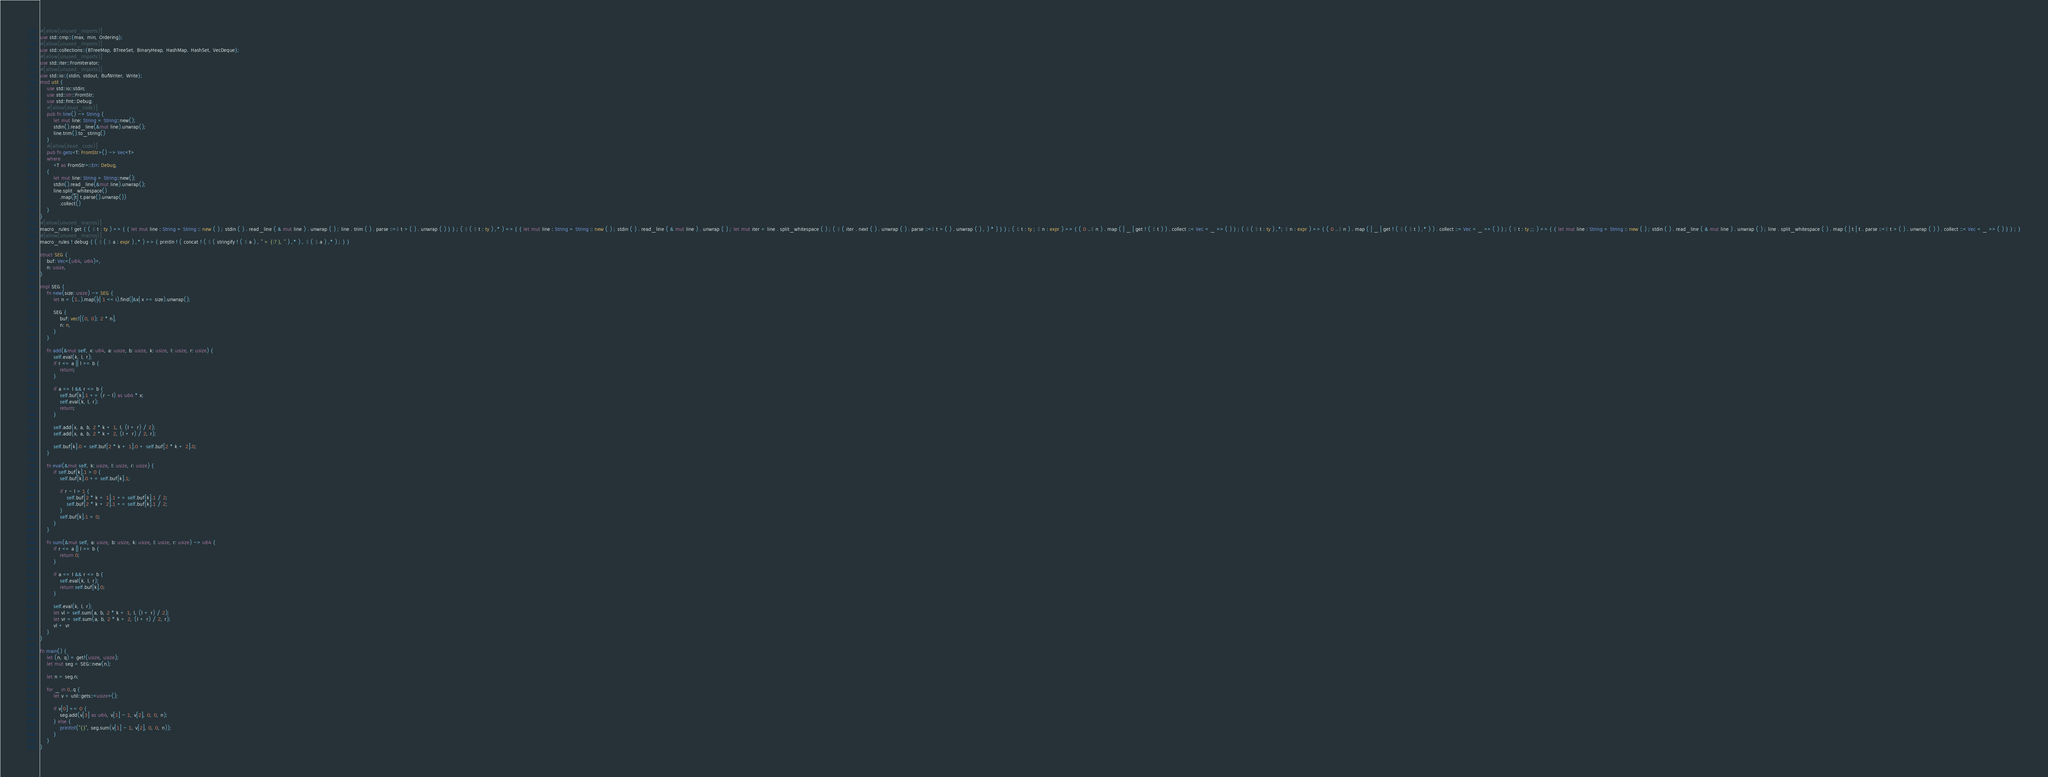<code> <loc_0><loc_0><loc_500><loc_500><_Rust_>#[allow(unused_imports)]
use std::cmp::{max, min, Ordering};
#[allow(unused_imports)]
use std::collections::{BTreeMap, BTreeSet, BinaryHeap, HashMap, HashSet, VecDeque};
#[allow(unused_imports)]
use std::iter::FromIterator;
#[allow(unused_imports)]
use std::io::{stdin, stdout, BufWriter, Write};
mod util {
    use std::io::stdin;
    use std::str::FromStr;
    use std::fmt::Debug;
    #[allow(dead_code)]
    pub fn line() -> String {
        let mut line: String = String::new();
        stdin().read_line(&mut line).unwrap();
        line.trim().to_string()
    }
    #[allow(dead_code)]
    pub fn gets<T: FromStr>() -> Vec<T>
    where
        <T as FromStr>::Err: Debug,
    {
        let mut line: String = String::new();
        stdin().read_line(&mut line).unwrap();
        line.split_whitespace()
            .map(|t| t.parse().unwrap())
            .collect()
    }
}
#[allow(unused_macros)]
macro_rules ! get { ( $ t : ty ) => { { let mut line : String = String :: new ( ) ; stdin ( ) . read_line ( & mut line ) . unwrap ( ) ; line . trim ( ) . parse ::<$ t > ( ) . unwrap ( ) } } ; ( $ ( $ t : ty ) ,* ) => { { let mut line : String = String :: new ( ) ; stdin ( ) . read_line ( & mut line ) . unwrap ( ) ; let mut iter = line . split_whitespace ( ) ; ( $ ( iter . next ( ) . unwrap ( ) . parse ::<$ t > ( ) . unwrap ( ) , ) * ) } } ; ( $ t : ty ; $ n : expr ) => { ( 0 ..$ n ) . map ( | _ | get ! ( $ t ) ) . collect ::< Vec < _ >> ( ) } ; ( $ ( $ t : ty ) ,*; $ n : expr ) => { ( 0 ..$ n ) . map ( | _ | get ! ( $ ( $ t ) ,* ) ) . collect ::< Vec < _ >> ( ) } ; ( $ t : ty ;; ) => { { let mut line : String = String :: new ( ) ; stdin ( ) . read_line ( & mut line ) . unwrap ( ) ; line . split_whitespace ( ) . map ( | t | t . parse ::<$ t > ( ) . unwrap ( ) ) . collect ::< Vec < _ >> ( ) } } ; }
#[allow(unused_macros)]
macro_rules ! debug { ( $ ( $ a : expr ) ,* ) => { println ! ( concat ! ( $ ( stringify ! ( $ a ) , " = {:?}, " ) ,* ) , $ ( $ a ) ,* ) ; } }

struct SEG {
    buf: Vec<(u64, u64)>,
    n: usize,
}

impl SEG {
    fn new(size: usize) -> SEG {
        let n = (1..).map(|i| 1 << i).find(|&x| x >= size).unwrap();

        SEG {
            buf: vec![(0, 0); 2 * n],
            n: n,
        }
    }

    fn add(&mut self, x: u64, a: usize, b: usize, k: usize, l: usize, r: usize) {
        self.eval(k, l, r);
        if r <= a || l >= b {
            return;
        }

        if a <= l && r <= b {
            self.buf[k].1 += (r - l) as u64 * x;
            self.eval(k, l, r);
            return;
        }

        self.add(x, a, b, 2 * k + 1, l, (l + r) / 2);
        self.add(x, a, b, 2 * k + 2, (l + r) / 2, r);

        self.buf[k].0 = self.buf[2 * k + 1].0 + self.buf[2 * k + 2].0;
    }

    fn eval(&mut self, k: usize, l: usize, r: usize) {
        if self.buf[k].1 > 0 {
            self.buf[k].0 += self.buf[k].1;

            if r - l > 1 {
                self.buf[2 * k + 1].1 += self.buf[k].1 / 2;
                self.buf[2 * k + 2].1 += self.buf[k].1 / 2;
            }
            self.buf[k].1 = 0;
        }
    }

    fn sum(&mut self, a: usize, b: usize, k: usize, l: usize, r: usize) -> u64 {
        if r <= a || l >= b {
            return 0;
        }

        if a <= l && r <= b {
            self.eval(k, l, r);
            return self.buf[k].0;
        }

        self.eval(k, l, r);
        let vl = self.sum(a, b, 2 * k + 1, l, (l + r) / 2);
        let vr = self.sum(a, b, 2 * k + 2, (l + r) / 2, r);
        vl + vr
    }
}

fn main() {
    let (n, q) = get!(usize, usize);
    let mut seg = SEG::new(n);

    let n = seg.n;

    for _ in 0..q {
        let v = util::gets::<usize>();

        if v[0] == 0 {
            seg.add(v[3] as u64, v[1] - 1, v[2], 0, 0, n);
        } else {
            println!("{}", seg.sum(v[1] - 1, v[2], 0, 0, n));
        }
    }
}

</code> 